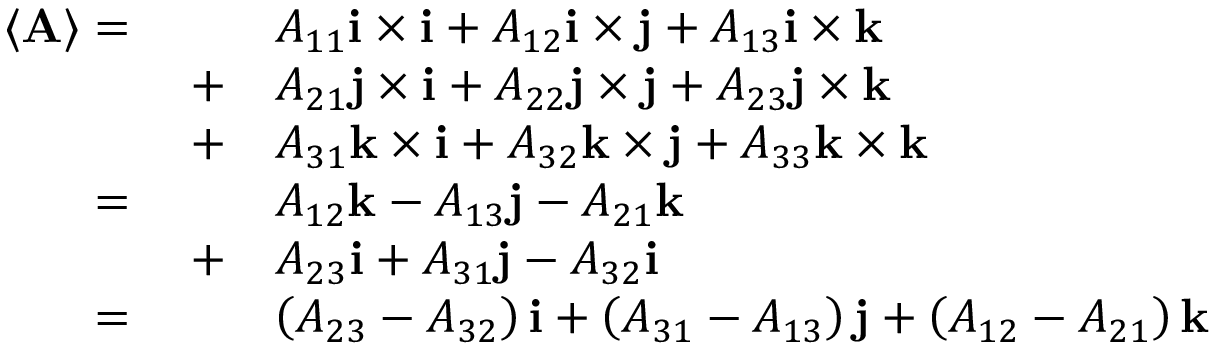Convert formula to latex. <formula><loc_0><loc_0><loc_500><loc_500>{ \begin{array} { r l } { \langle A \rangle = \quad } & { A _ { 1 1 } i \times i + A _ { 1 2 } i \times j + A _ { 1 3 } i \times k } \\ { + } & { A _ { 2 1 } j \times i + A _ { 2 2 } j \times j + A _ { 2 3 } j \times k } \\ { + } & { A _ { 3 1 } k \times i + A _ { 3 2 } k \times j + A _ { 3 3 } k \times k } \\ { = \quad } & { A _ { 1 2 } k - A _ { 1 3 } j - A _ { 2 1 } k } \\ { + } & { A _ { 2 3 } i + A _ { 3 1 } j - A _ { 3 2 } i } \\ { = \quad } & { \left ( A _ { 2 3 } - A _ { 3 2 } \right ) i + \left ( A _ { 3 1 } - A _ { 1 3 } \right ) j + \left ( A _ { 1 2 } - A _ { 2 1 } \right ) k } \end{array} }</formula> 